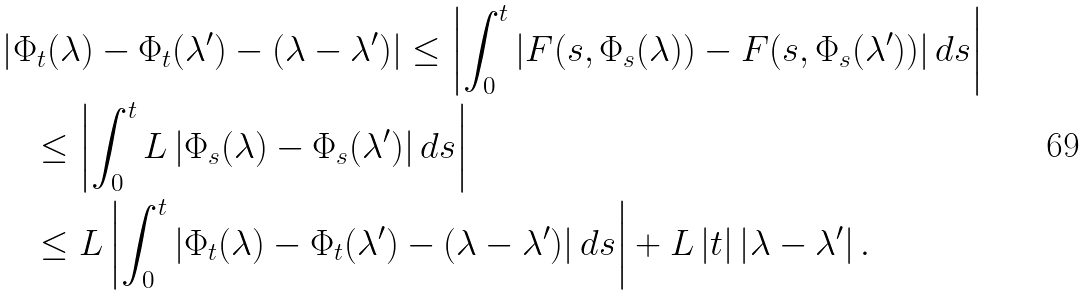<formula> <loc_0><loc_0><loc_500><loc_500>& \left | \Phi _ { t } ( \lambda ) - \Phi _ { t } ( \lambda ^ { \prime } ) - ( \lambda - \lambda ^ { \prime } ) \right | \leq \left | \int _ { 0 } ^ { t } \left | F ( s , \Phi _ { s } ( \lambda ) ) - F ( s , \Phi _ { s } ( \lambda ^ { \prime } ) ) \right | d s \right | \\ & \quad \leq \left | \int _ { 0 } ^ { t } L \left | \Phi _ { s } ( \lambda ) - \Phi _ { s } ( \lambda ^ { \prime } ) \right | d s \right | \\ & \quad \leq L \left | \int _ { 0 } ^ { t } \left | \Phi _ { t } ( \lambda ) - \Phi _ { t } ( \lambda ^ { \prime } ) - ( \lambda - \lambda ^ { \prime } ) \right | d s \right | + L \left | t \right | \left | \lambda - \lambda ^ { \prime } \right | .</formula> 